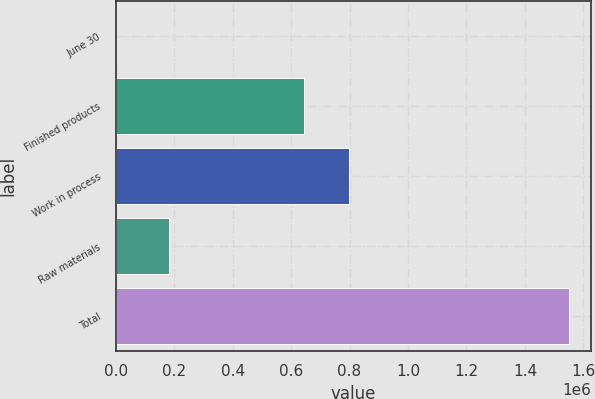<chart> <loc_0><loc_0><loc_500><loc_500><bar_chart><fcel>June 30<fcel>Finished products<fcel>Work in process<fcel>Raw materials<fcel>Total<nl><fcel>2017<fcel>642788<fcel>797536<fcel>183573<fcel>1.54949e+06<nl></chart> 